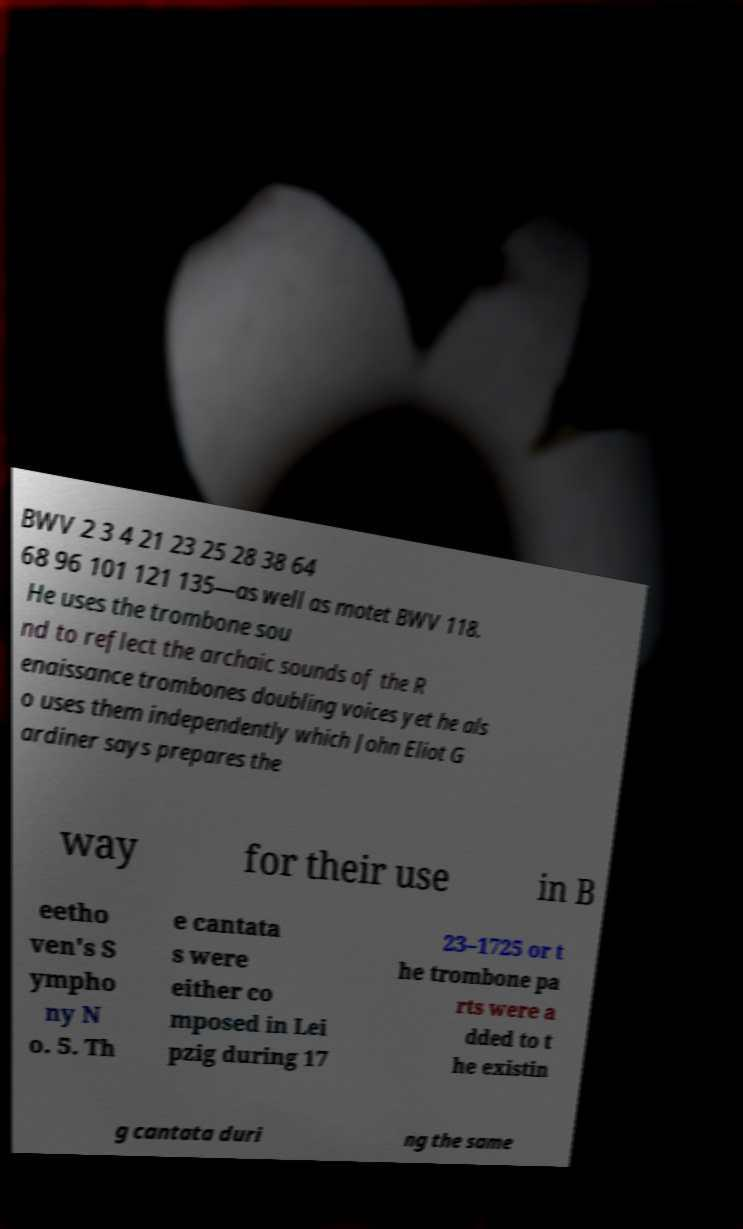Could you extract and type out the text from this image? BWV 2 3 4 21 23 25 28 38 64 68 96 101 121 135—as well as motet BWV 118. He uses the trombone sou nd to reflect the archaic sounds of the R enaissance trombones doubling voices yet he als o uses them independently which John Eliot G ardiner says prepares the way for their use in B eetho ven's S ympho ny N o. 5. Th e cantata s were either co mposed in Lei pzig during 17 23–1725 or t he trombone pa rts were a dded to t he existin g cantata duri ng the same 